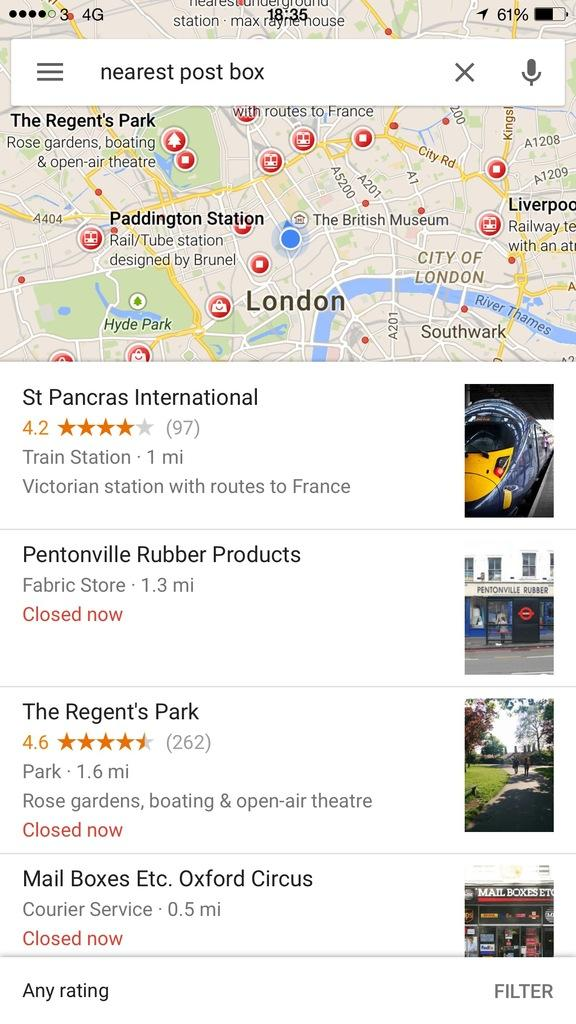What type of image is shown in the screenshot? The image is a screenshot. What can be seen within the screenshot? There are pictures and text visible in the screenshot. How many bells are hanging from the houses in the screenshot? There are no houses or bells present in the screenshot; it only contains pictures and text. What type of party is being depicted in the screenshot? There is no party depicted in the screenshot; it only contains pictures and text. 